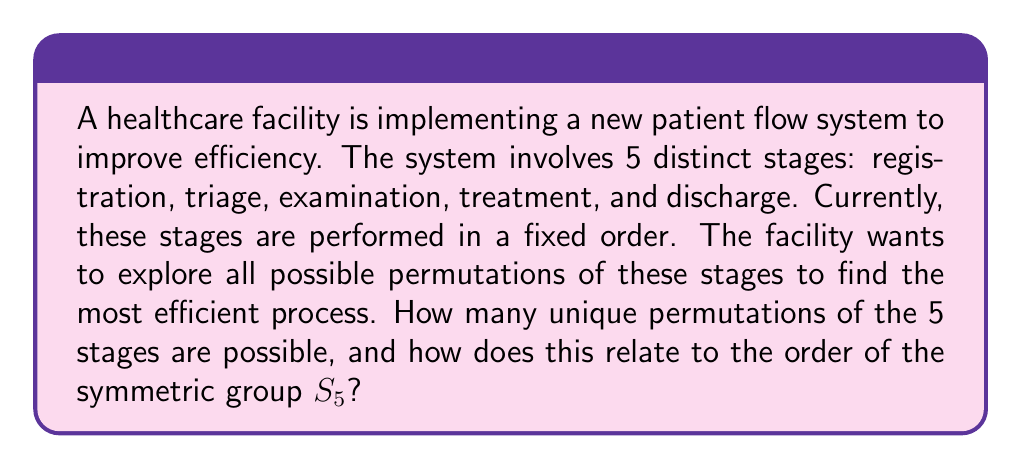Help me with this question. To solve this problem, we need to understand the concept of permutations and their relation to symmetric groups in Group theory.

1. Permutations:
   A permutation is an arrangement of objects in a specific order. In this case, we have 5 distinct stages that can be arranged in different orders.

2. Calculating the number of permutations:
   The number of permutations of n distinct objects is given by n!
   In this case, n = 5, so the number of permutations = 5!
   
   $$5! = 5 \times 4 \times 3 \times 2 \times 1 = 120$$

3. Relation to the symmetric group $S_5$:
   The symmetric group $S_n$ is the group of all permutations on n objects. The order of a group is the number of elements in the group.

   In this case, the symmetric group $S_5$ consists of all permutations of 5 objects.
   The order of $S_5$, denoted as $|S_5|$, is equal to the number of permutations of 5 objects.

   $$|S_5| = 5! = 120$$

4. Interpretation in the healthcare context:
   This result means that there are 120 different ways to arrange the 5 stages of the patient flow process. Each of these permutations represents a unique process flow that the healthcare facility could potentially implement.

   By exploring these 120 permutations, the facility can analyze which arrangement leads to the most efficient patient flow, potentially reducing wait times and improving overall operational efficiency.
Answer: There are 120 unique permutations of the 5 stages, which is equal to the order of the symmetric group $S_5$, i.e., $|S_5| = 5! = 120$. 